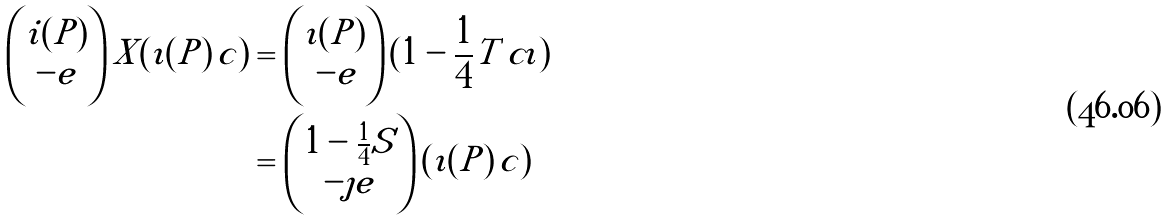<formula> <loc_0><loc_0><loc_500><loc_500>\begin{pmatrix} i ( P ) \\ - e \end{pmatrix} X ( \imath ( P ) \, c ) & = \begin{pmatrix} \imath ( P ) \\ \, - e \end{pmatrix} ( 1 - \frac { 1 } { 4 } T \, c \imath ) \\ & = \begin{pmatrix} 1 - \frac { 1 } { 4 } S \\ - \jmath e \end{pmatrix} ( \imath ( P ) \, c )</formula> 